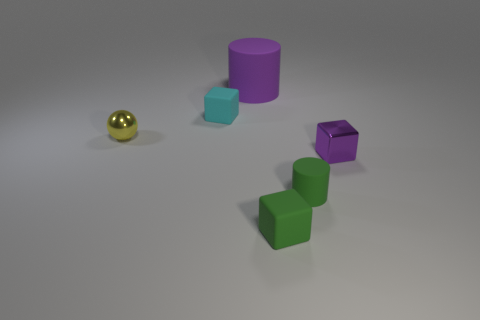Add 1 large red shiny things. How many objects exist? 7 Subtract all cylinders. How many objects are left? 4 Add 3 tiny cyan objects. How many tiny cyan objects are left? 4 Add 2 tiny brown shiny things. How many tiny brown shiny things exist? 2 Subtract 0 red cylinders. How many objects are left? 6 Subtract all big cyan metal balls. Subtract all green rubber cubes. How many objects are left? 5 